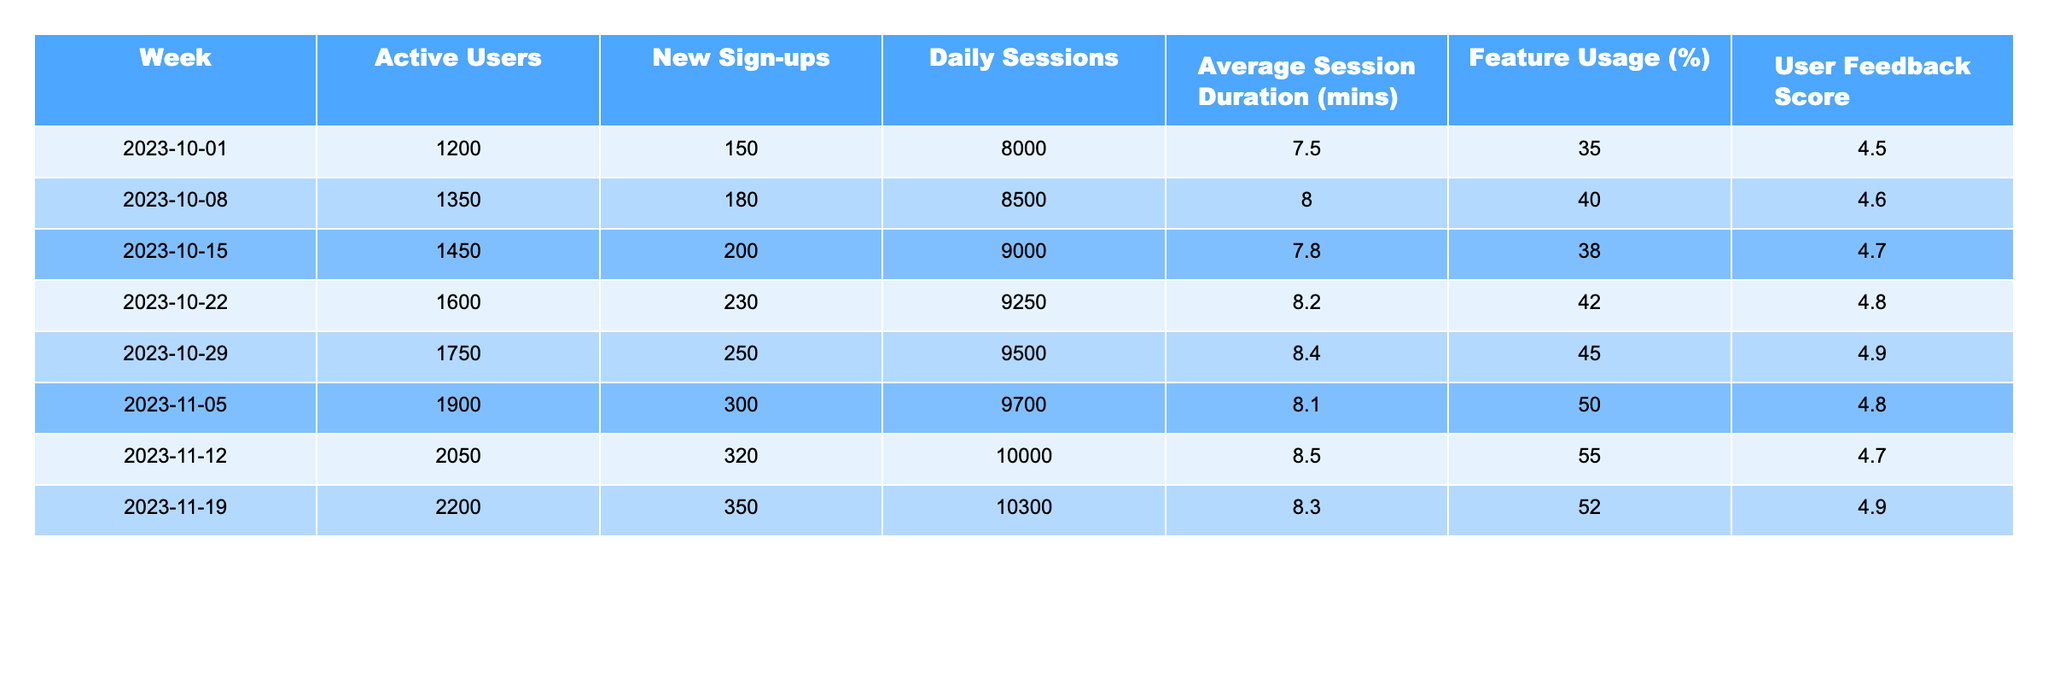What was the user feedback score in the week of October 29, 2023? According to the table, the user feedback score for the week of October 29, 2023, is listed in the respective row. I can directly see it in the table and it is 4.9.
Answer: 4.9 How many active users were there on November 12, 2023? The number of active users for November 12, 2023, is found in that specific week's row. It shows that there were 2050 active users.
Answer: 2050 What is the total number of new sign-ups over the first four weeks? To find the total, we sum the new sign-ups for the first four weeks: 150 + 180 + 200 + 230 = 760.
Answer: 760 What was the average session duration during the week of November 5, 2023? The table shows the average session duration for November 5, 2023 as 8.1 minutes.
Answer: 8.1 Did the average session duration increase from October 1 to November 19? Checking the values, October 1 shows 7.5 minutes and November 19 shows 8.3 minutes. Since 8.3 is greater than 7.5, it confirms an increase.
Answer: Yes Which week had the highest number of daily sessions? By comparing the daily sessions across the weeks, I see that the week of November 19 shows the highest value at 10300 sessions.
Answer: 10300 What is the difference in active users between October 1 and October 22, 2023? The active users for October 1 is 1200 and for October 22 is 1600. The difference is calculated as 1600 - 1200 = 400.
Answer: 400 What percentage of feature usage was reported for the week of November 5? The feature usage reported for November 5, 2023, is stated in the table as 50%.
Answer: 50% How many new sign-ups were there in the week of October 15 compared to the week of October 29? For October 15, there were 200 new sign-ups, and for October 29 there were 250. The difference is 250 - 200 = 50 more in the week of October 29.
Answer: 50 If the trend continues, how many active users could be expected in the week after November 19? The active users have been increasing weekly: (1200, 1350, 1450, 1600, 1750, 1900, 2050, 2200). The increase averages to about 100 additional active users per week. Thus, we can expect around 2200 + 100 = 2300.
Answer: 2300 